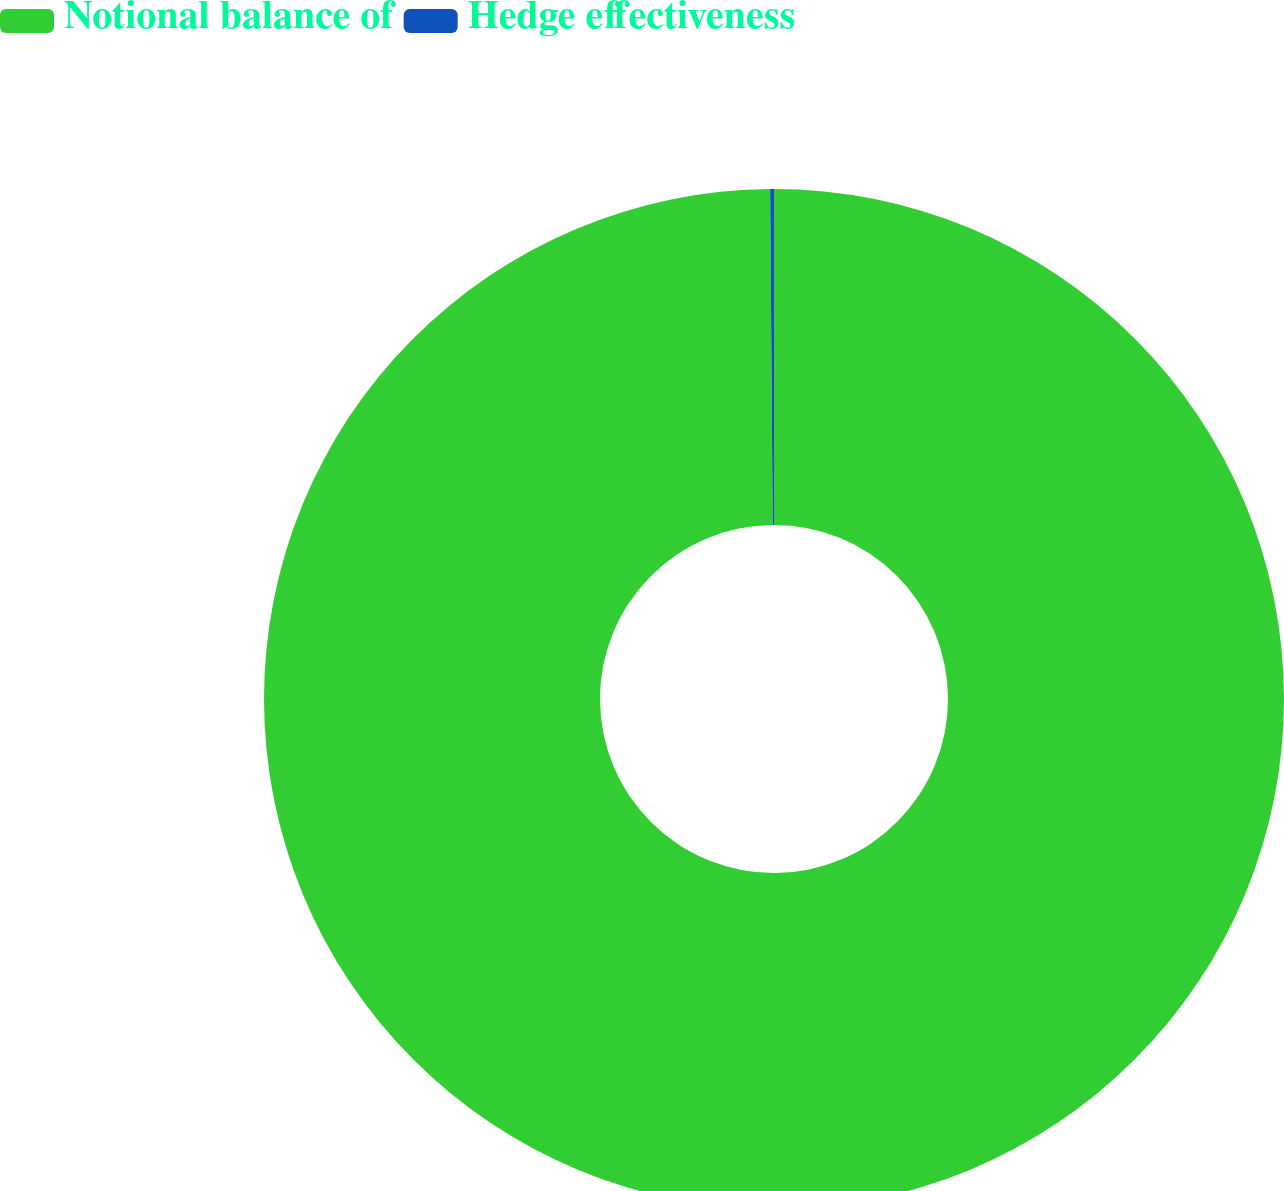<chart> <loc_0><loc_0><loc_500><loc_500><pie_chart><fcel>Notional balance of<fcel>Hedge effectiveness<nl><fcel>99.88%<fcel>0.12%<nl></chart> 